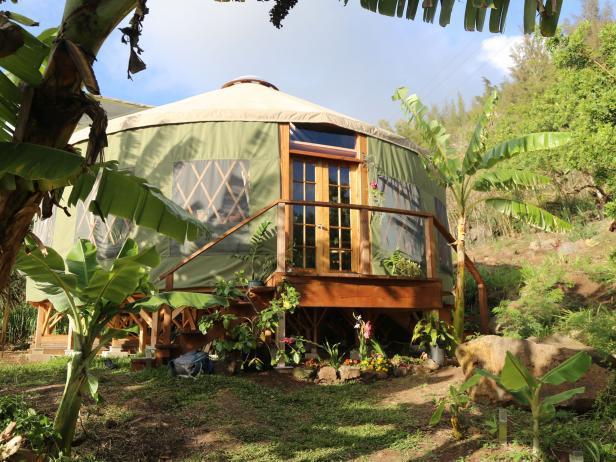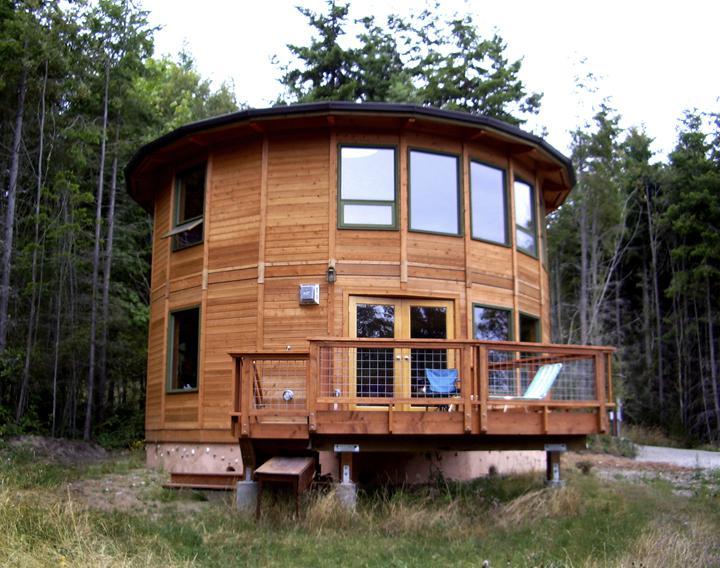The first image is the image on the left, the second image is the image on the right. Analyze the images presented: Is the assertion "All of the roofs are visible and tan" valid? Answer yes or no. No. The first image is the image on the left, the second image is the image on the right. For the images displayed, is the sentence "Multiple people are visible outside one of the tents/yurts." factually correct? Answer yes or no. No. 